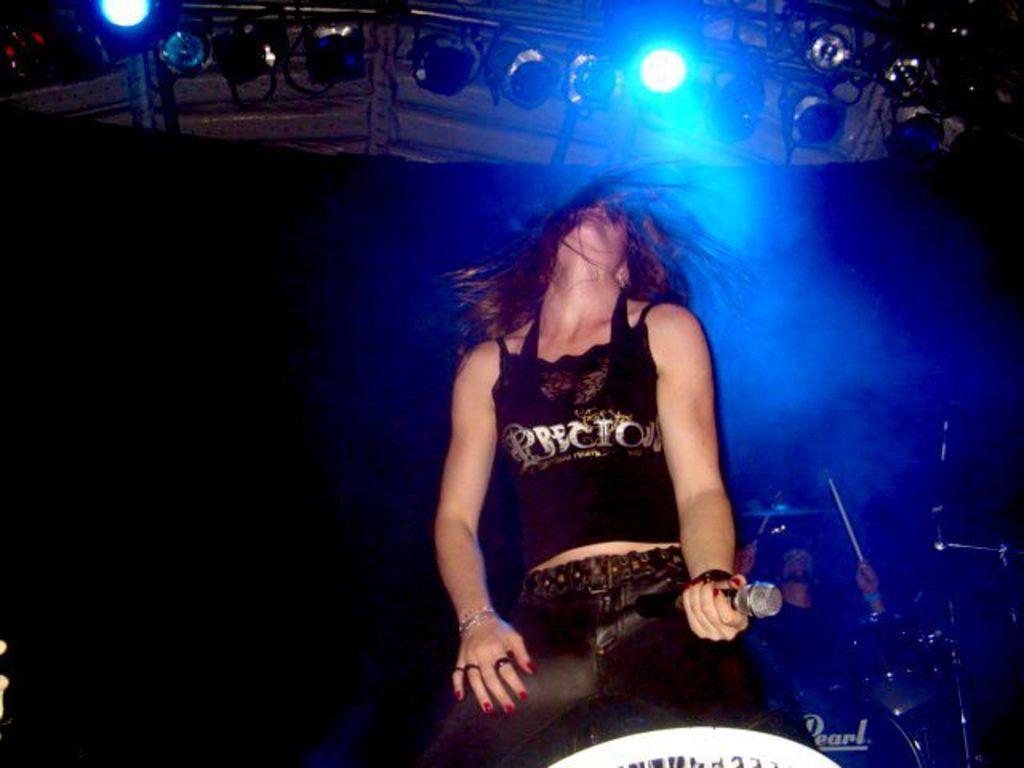Could you give a brief overview of what you see in this image? In this picture there is a girl wearing black top and jeans is singing on the stage. Behind there is a band and on the top we can see some blue color spotlights. 